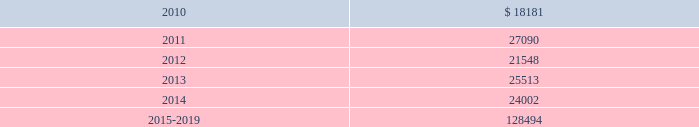Mastercard incorporated notes to consolidated financial statements 2014 ( continued ) ( in thousands , except percent and per share data ) the table summarizes expected benefit payments through 2019 for the pension plans , including those payments expected to be paid from the company 2019s general assets .
Since the majority of the benefit payments are made in the form of lump-sum distributions , actual benefit payments may differ from expected benefit payments. .
Substantially all of the company 2019s u.s .
Employees are eligible to participate in a defined contribution savings plan ( the 201csavings plan 201d ) sponsored by the company .
The savings plan allows employees to contribute a portion of their base compensation on a pre-tax and after-tax basis in accordance with specified guidelines .
The company matches a percentage of employees 2019 contributions up to certain limits .
In 2007 and prior years , the company could also contribute to the savings plan a discretionary profit sharing component linked to company performance during the prior year .
Beginning in 2008 , the discretionary profit sharing amount related to prior year company performance was paid directly to employees as a short-term cash incentive bonus rather than as a contribution to the savings plan .
In addition , the company has several defined contribution plans outside of the united states .
The company 2019s contribution expense related to all of its defined contribution plans was $ 40627 , $ 35341 and $ 26996 for 2009 , 2008 and 2007 , respectively .
Note 13 .
Postemployment and postretirement benefits the company maintains a postretirement plan ( the 201cpostretirement plan 201d ) providing health coverage and life insurance benefits for substantially all of its u.s .
Employees hired before july 1 , 2007 .
The company amended the life insurance benefits under the postretirement plan effective january 1 , 2007 .
The impact , net of taxes , of this amendment was an increase of $ 1715 to accumulated other comprehensive income in 2007 .
In 2009 , the company recorded a $ 3944 benefit expense as a result of enhanced postretirement medical benefits under the postretirement plan provided to employees that chose to participate in a voluntary transition program. .
What is the increase observed in the expected benefit payments during 2012 and 2013? 
Rationale: it is the expected benefit payment's value in 2013 divided by the 2012's , then transformed into a percentage .
Computations: ((25513 / 21548) - 1)
Answer: 0.18401. 